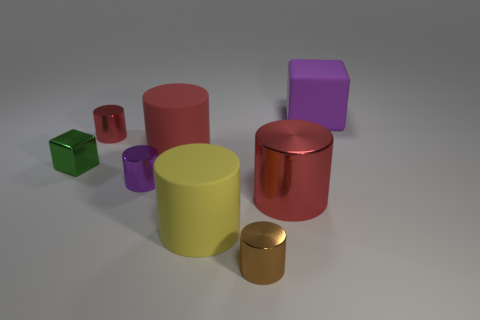Subtract all red balls. How many red cylinders are left? 3 Subtract all purple cylinders. How many cylinders are left? 5 Subtract all brown cylinders. How many cylinders are left? 5 Subtract 3 cylinders. How many cylinders are left? 3 Subtract all brown cylinders. Subtract all gray cubes. How many cylinders are left? 5 Add 1 shiny cubes. How many objects exist? 9 Subtract all blocks. How many objects are left? 6 Subtract all large blue cylinders. Subtract all metallic blocks. How many objects are left? 7 Add 1 large cylinders. How many large cylinders are left? 4 Add 3 small brown metallic cylinders. How many small brown metallic cylinders exist? 4 